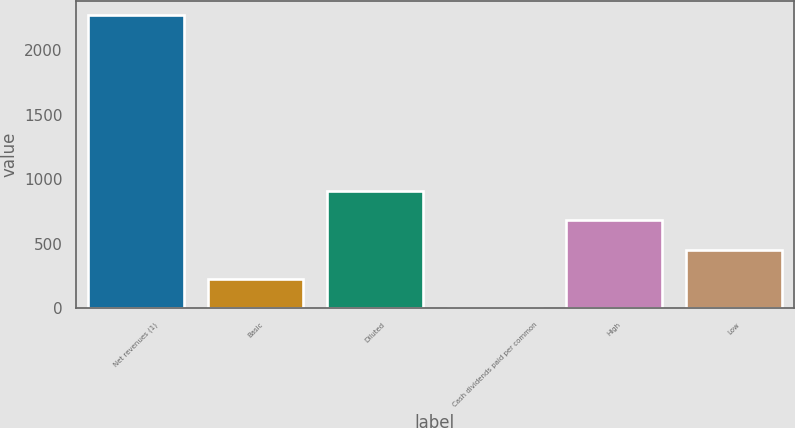Convert chart. <chart><loc_0><loc_0><loc_500><loc_500><bar_chart><fcel>Net revenues (1)<fcel>Basic<fcel>Diluted<fcel>Cash dividends paid per common<fcel>High<fcel>Low<nl><fcel>2269<fcel>227.05<fcel>907.69<fcel>0.17<fcel>680.81<fcel>453.93<nl></chart> 